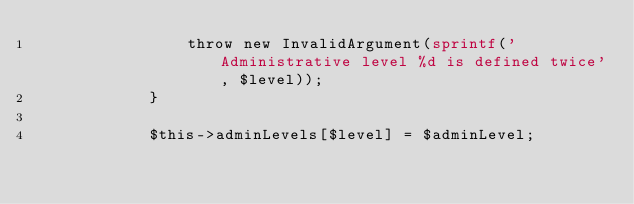<code> <loc_0><loc_0><loc_500><loc_500><_PHP_>                throw new InvalidArgument(sprintf('Administrative level %d is defined twice', $level));
            }

            $this->adminLevels[$level] = $adminLevel;</code> 